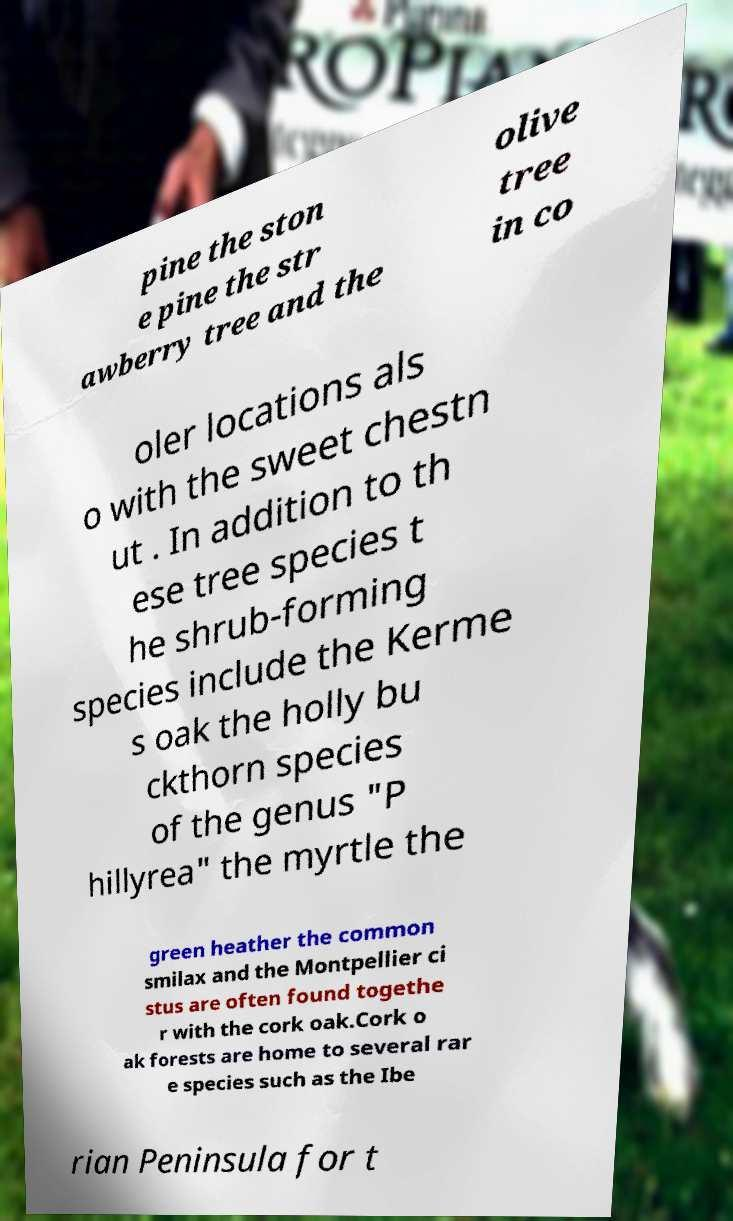Can you accurately transcribe the text from the provided image for me? pine the ston e pine the str awberry tree and the olive tree in co oler locations als o with the sweet chestn ut . In addition to th ese tree species t he shrub-forming species include the Kerme s oak the holly bu ckthorn species of the genus "P hillyrea" the myrtle the green heather the common smilax and the Montpellier ci stus are often found togethe r with the cork oak.Cork o ak forests are home to several rar e species such as the Ibe rian Peninsula for t 